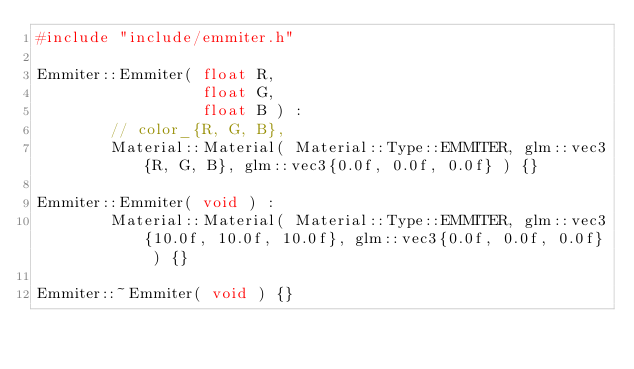<code> <loc_0><loc_0><loc_500><loc_500><_C++_>#include "include/emmiter.h"

Emmiter::Emmiter( float R,
                  float G,
                  float B ) :
        // color_{R, G, B},
        Material::Material( Material::Type::EMMITER, glm::vec3{R, G, B}, glm::vec3{0.0f, 0.0f, 0.0f} ) {}

Emmiter::Emmiter( void ) :
        Material::Material( Material::Type::EMMITER, glm::vec3{10.0f, 10.0f, 10.0f}, glm::vec3{0.0f, 0.0f, 0.0f} ) {}

Emmiter::~Emmiter( void ) {}</code> 